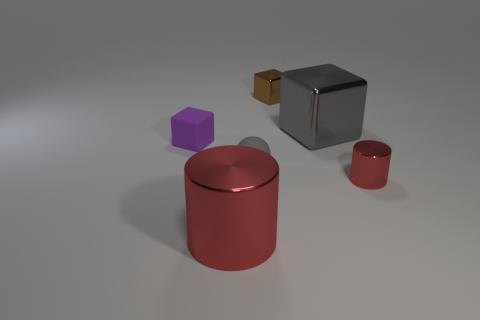Add 1 brown rubber cylinders. How many objects exist? 7 Subtract all small rubber blocks. How many blocks are left? 2 Subtract all spheres. How many objects are left? 5 Subtract all brown blocks. How many blocks are left? 2 Subtract all purple cylinders. Subtract all yellow cubes. How many cylinders are left? 2 Subtract all large brown rubber blocks. Subtract all big gray metal things. How many objects are left? 5 Add 6 matte balls. How many matte balls are left? 7 Add 2 yellow things. How many yellow things exist? 2 Subtract 0 cyan balls. How many objects are left? 6 Subtract 1 cylinders. How many cylinders are left? 1 